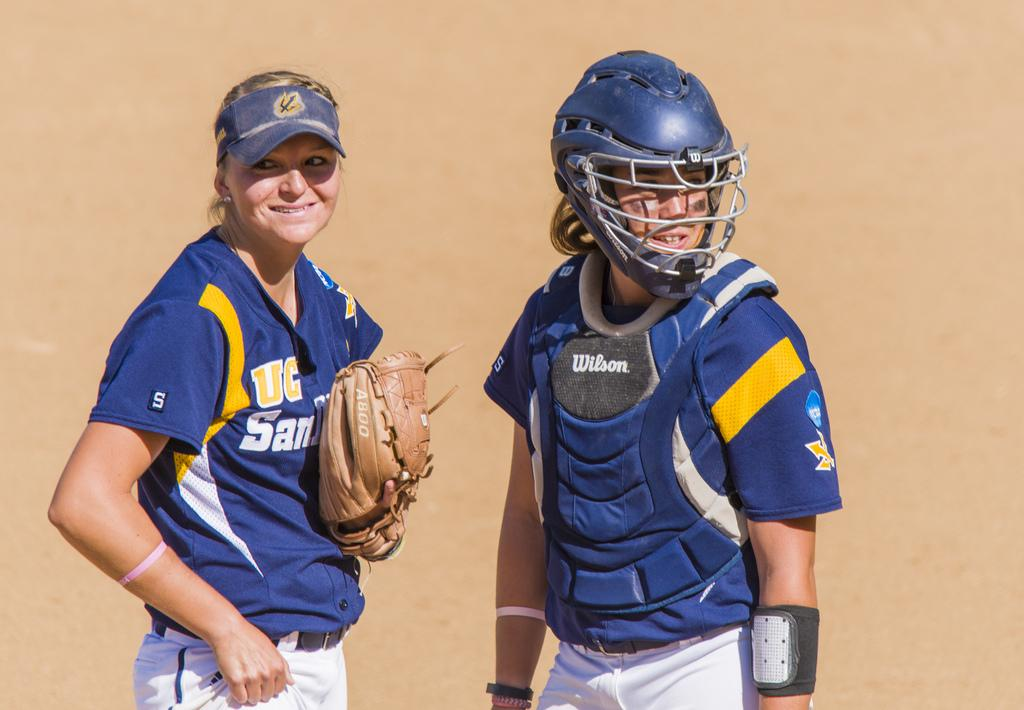<image>
Summarize the visual content of the image. Two women's softball players from UC San Diego stand next to each other. 